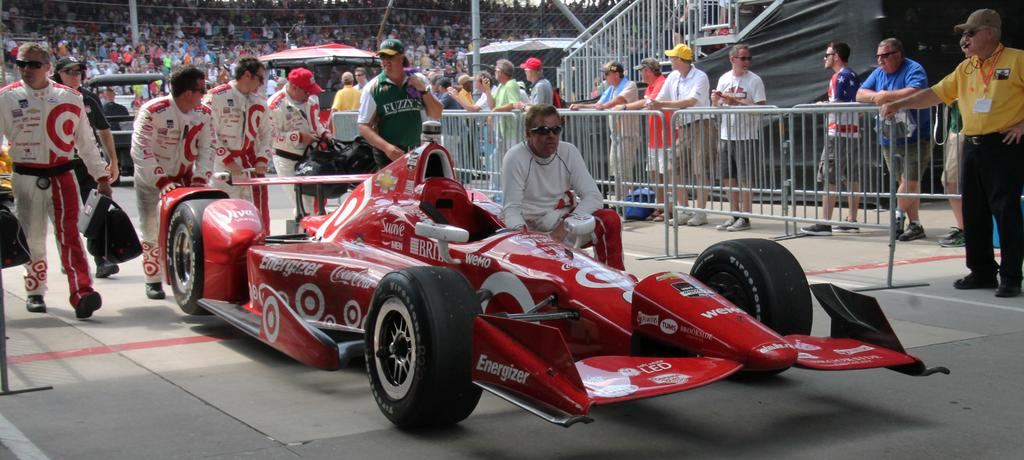What are the people in the image doing? There is a group of people standing on the ground in the image. What else can be seen in the image besides the people? There are vehicles, a fence, poles, and other objects present in the image. Can you see a kitty smiling among the plants in the image? There is no kitty or plants present in the image. 